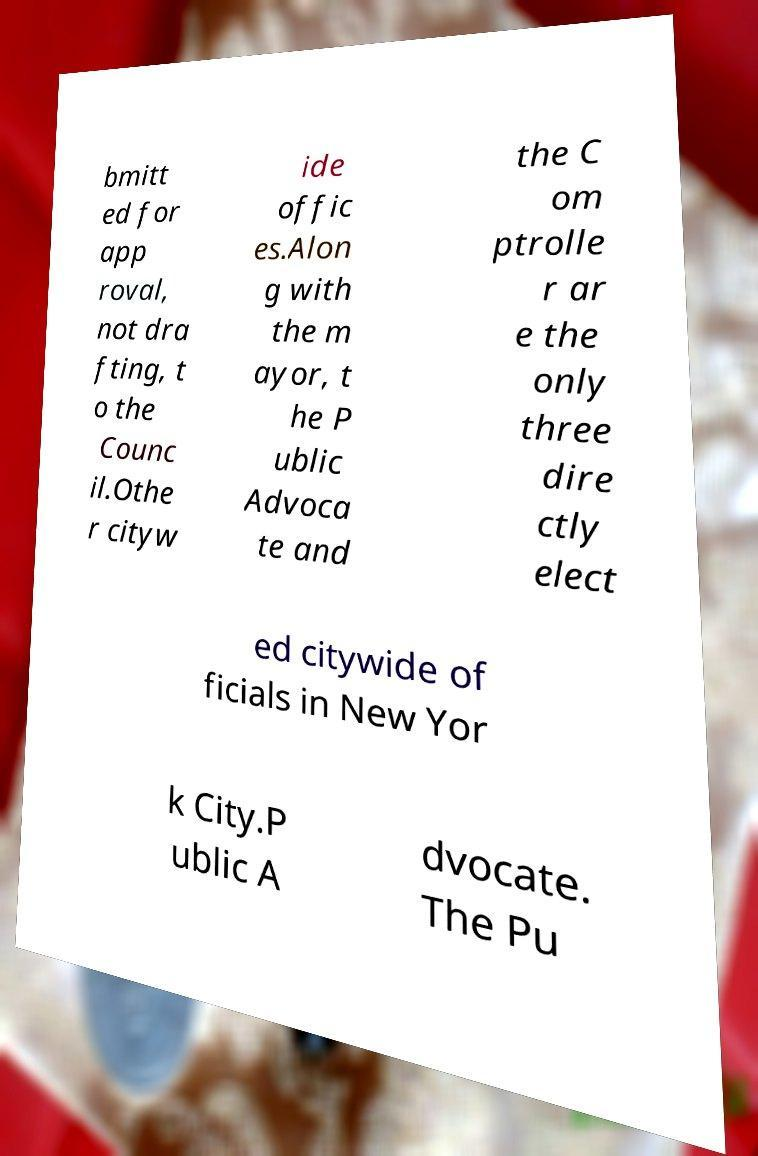Could you extract and type out the text from this image? bmitt ed for app roval, not dra fting, t o the Counc il.Othe r cityw ide offic es.Alon g with the m ayor, t he P ublic Advoca te and the C om ptrolle r ar e the only three dire ctly elect ed citywide of ficials in New Yor k City.P ublic A dvocate. The Pu 